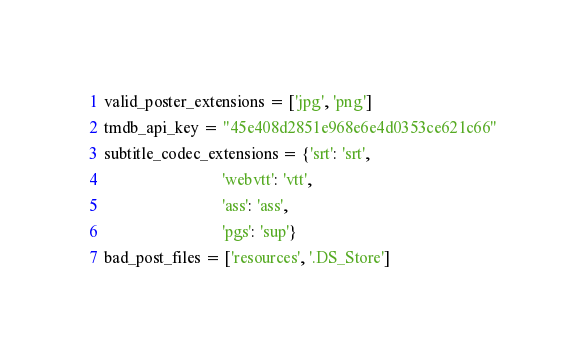Convert code to text. <code><loc_0><loc_0><loc_500><loc_500><_Python_>valid_poster_extensions = ['jpg', 'png']
tmdb_api_key = "45e408d2851e968e6e4d0353ce621c66"
subtitle_codec_extensions = {'srt': 'srt',
                             'webvtt': 'vtt',
                             'ass': 'ass',
                             'pgs': 'sup'}
bad_post_files = ['resources', '.DS_Store']</code> 